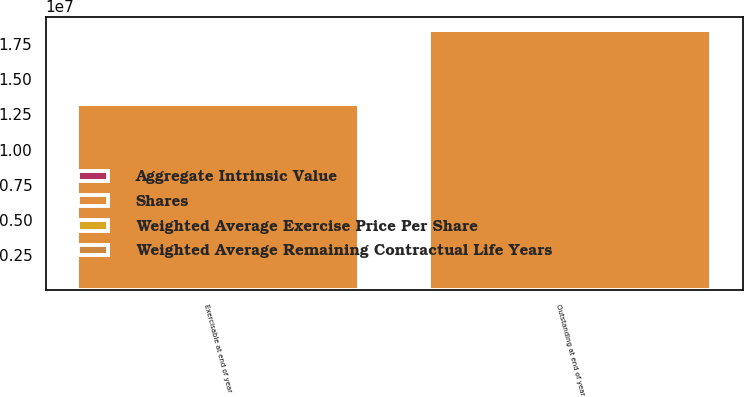<chart> <loc_0><loc_0><loc_500><loc_500><stacked_bar_chart><ecel><fcel>Outstanding at end of year<fcel>Exercisable at end of year<nl><fcel>Shares<fcel>1.85046e+07<fcel>1.3216e+07<nl><fcel>Aggregate Intrinsic Value<fcel>73.75<fcel>72.74<nl><fcel>Weighted Average Exercise Price Per Share<fcel>5.93<fcel>5.1<nl><fcel>Weighted Average Remaining Contractual Life Years<fcel>1041<fcel>757<nl></chart> 